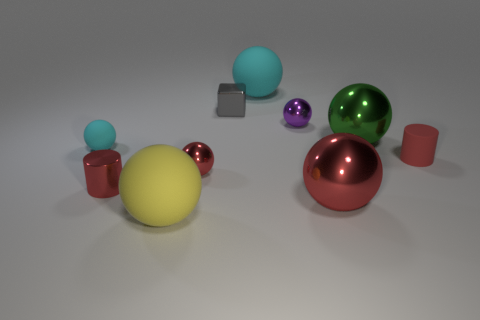What shape is the small matte object that is the same color as the metallic cylinder?
Your answer should be compact. Cylinder. There is a tiny matte object that is right of the rubber ball that is to the left of the big rubber sphere that is in front of the gray shiny cube; what shape is it?
Your response must be concise. Cylinder. Is the number of cylinders that are left of the small purple ball the same as the number of purple objects?
Give a very brief answer. Yes. What is the size of the metal cylinder that is the same color as the matte cylinder?
Provide a succinct answer. Small. Is the big red thing the same shape as the small purple object?
Ensure brevity in your answer.  Yes. What number of things are either small metal spheres that are in front of the green shiny thing or small red balls?
Make the answer very short. 1. Are there the same number of large yellow things right of the tiny matte ball and tiny red things that are left of the purple thing?
Offer a terse response. No. How many other things are there of the same shape as the red matte thing?
Provide a succinct answer. 1. There is a red thing to the left of the large yellow matte thing; does it have the same size as the matte thing that is in front of the small red rubber thing?
Your response must be concise. No. How many spheres are either gray objects or green metal things?
Make the answer very short. 1. 